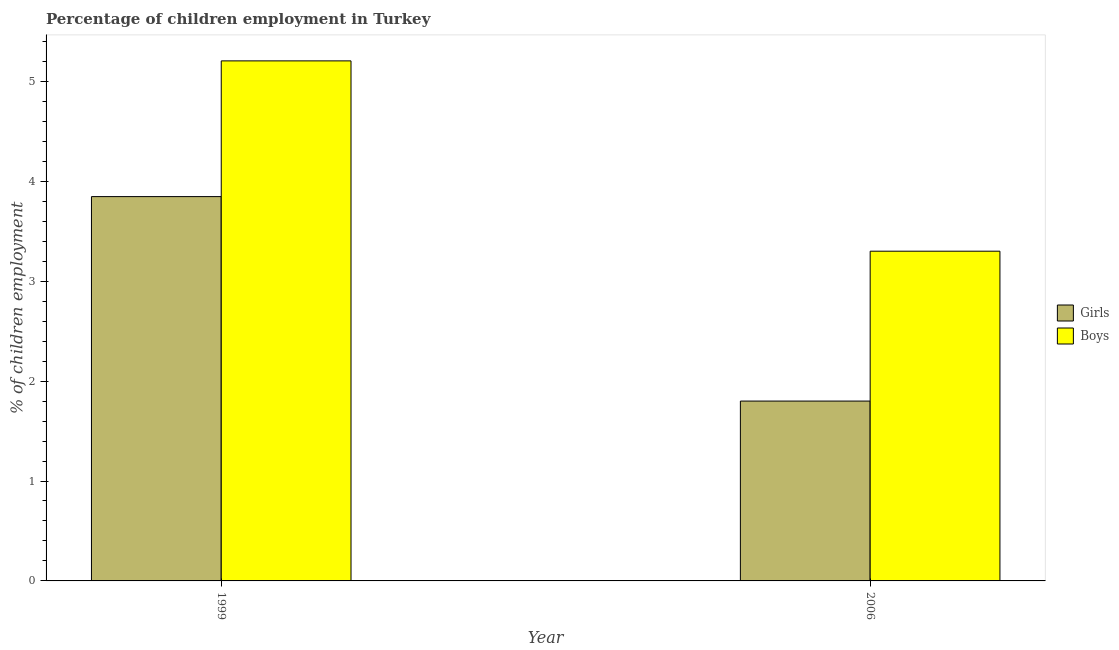Are the number of bars per tick equal to the number of legend labels?
Give a very brief answer. Yes. Are the number of bars on each tick of the X-axis equal?
Make the answer very short. Yes. How many bars are there on the 1st tick from the right?
Your answer should be compact. 2. What is the percentage of employed girls in 2006?
Make the answer very short. 1.8. Across all years, what is the maximum percentage of employed girls?
Provide a succinct answer. 3.85. What is the total percentage of employed girls in the graph?
Make the answer very short. 5.65. What is the difference between the percentage of employed girls in 1999 and that in 2006?
Your answer should be very brief. 2.05. What is the difference between the percentage of employed boys in 2006 and the percentage of employed girls in 1999?
Your response must be concise. -1.9. What is the average percentage of employed girls per year?
Your answer should be very brief. 2.82. In the year 2006, what is the difference between the percentage of employed girls and percentage of employed boys?
Provide a succinct answer. 0. What is the ratio of the percentage of employed girls in 1999 to that in 2006?
Ensure brevity in your answer.  2.14. What does the 2nd bar from the left in 2006 represents?
Provide a short and direct response. Boys. What does the 2nd bar from the right in 1999 represents?
Provide a succinct answer. Girls. How many years are there in the graph?
Offer a very short reply. 2. What is the difference between two consecutive major ticks on the Y-axis?
Your response must be concise. 1. Does the graph contain any zero values?
Give a very brief answer. No. Does the graph contain grids?
Provide a short and direct response. No. Where does the legend appear in the graph?
Offer a terse response. Center right. How many legend labels are there?
Your answer should be compact. 2. What is the title of the graph?
Provide a short and direct response. Percentage of children employment in Turkey. What is the label or title of the Y-axis?
Ensure brevity in your answer.  % of children employment. What is the % of children employment of Girls in 1999?
Provide a short and direct response. 3.85. What is the % of children employment in Boys in 1999?
Your answer should be very brief. 5.2. What is the % of children employment in Girls in 2006?
Your response must be concise. 1.8. Across all years, what is the maximum % of children employment in Girls?
Provide a short and direct response. 3.85. Across all years, what is the maximum % of children employment of Boys?
Offer a terse response. 5.2. Across all years, what is the minimum % of children employment of Girls?
Offer a very short reply. 1.8. What is the total % of children employment of Girls in the graph?
Make the answer very short. 5.65. What is the total % of children employment of Boys in the graph?
Provide a succinct answer. 8.5. What is the difference between the % of children employment in Girls in 1999 and that in 2006?
Your answer should be very brief. 2.05. What is the difference between the % of children employment in Boys in 1999 and that in 2006?
Give a very brief answer. 1.9. What is the difference between the % of children employment in Girls in 1999 and the % of children employment in Boys in 2006?
Your answer should be very brief. 0.55. What is the average % of children employment of Girls per year?
Ensure brevity in your answer.  2.82. What is the average % of children employment of Boys per year?
Keep it short and to the point. 4.25. In the year 1999, what is the difference between the % of children employment in Girls and % of children employment in Boys?
Ensure brevity in your answer.  -1.36. In the year 2006, what is the difference between the % of children employment of Girls and % of children employment of Boys?
Keep it short and to the point. -1.5. What is the ratio of the % of children employment of Girls in 1999 to that in 2006?
Make the answer very short. 2.14. What is the ratio of the % of children employment in Boys in 1999 to that in 2006?
Keep it short and to the point. 1.58. What is the difference between the highest and the second highest % of children employment in Girls?
Make the answer very short. 2.05. What is the difference between the highest and the second highest % of children employment of Boys?
Offer a terse response. 1.9. What is the difference between the highest and the lowest % of children employment of Girls?
Offer a terse response. 2.05. What is the difference between the highest and the lowest % of children employment of Boys?
Your response must be concise. 1.9. 